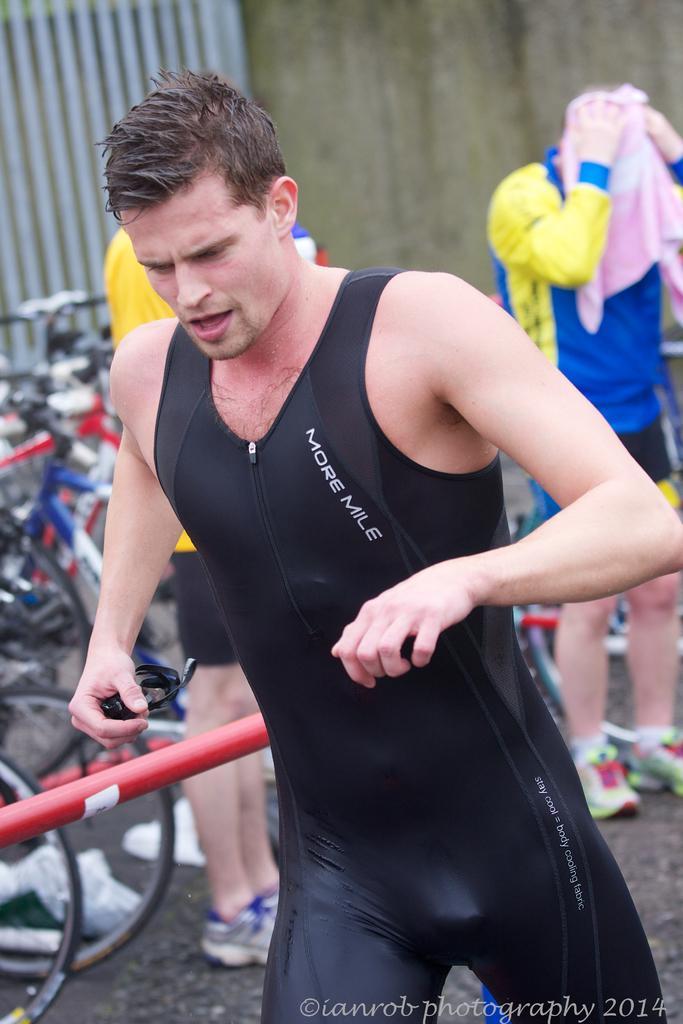In one or two sentences, can you explain what this image depicts? As we can see in the image there is a man who is running and he is holding a black sunglasses and he is wearing a black outfit and behind him there is a man who is drying his hair through towel and he is wearing shoes and he is wearing a jacket which is in blue and yellow colour and behind the man there are lot of bicycles parked on the road. 